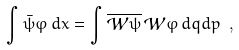<formula> <loc_0><loc_0><loc_500><loc_500>\int \bar { \psi } \varphi \, d x = \int \overline { \mathcal { W } \psi } \, \mathcal { W } \varphi \, d q d p \ ,</formula> 